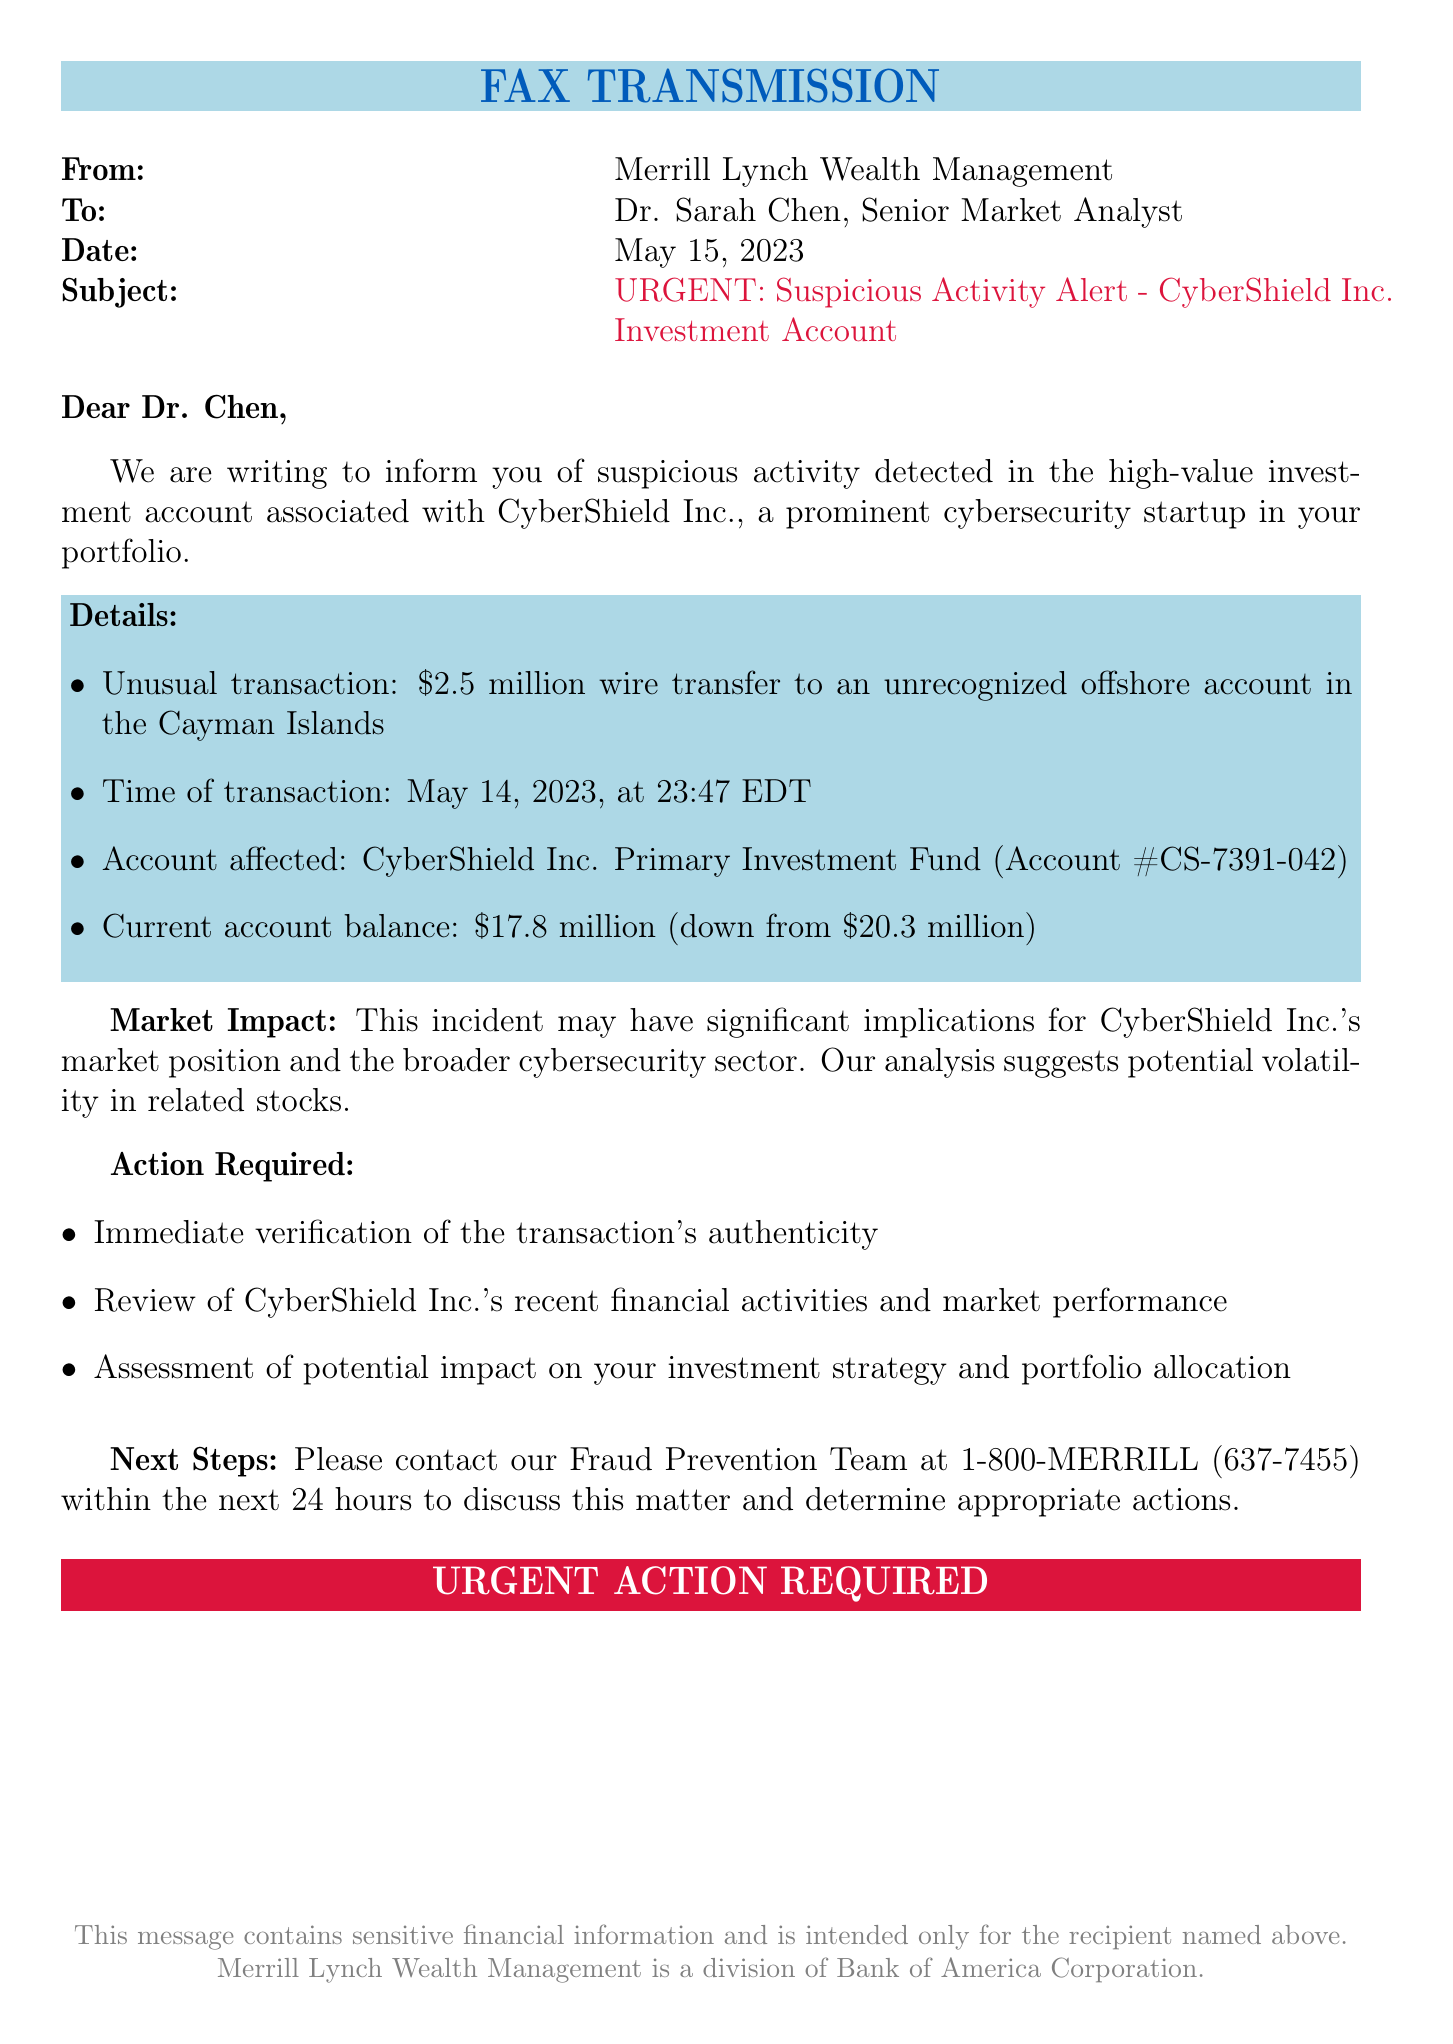What is the name of the company involved? The document highlights CyberShield Inc. as the company associated with the suspicious activity.
Answer: CyberShield Inc What is the amount of the suspicious transaction? The document specifies that the unusual transaction was a wire transfer of $2.5 million.
Answer: $2.5 million When did the suspicious transaction occur? The document states that the transaction took place on May 14, 2023, at 23:47 EDT.
Answer: May 14, 2023 What was the account balance before the suspicious transaction? The document indicates that the current account balance was $17.8 million, which was down from $20.3 million.
Answer: $20.3 million What action is required regarding the transaction's authenticity? The document requests immediate verification of the transaction's authenticity.
Answer: Immediate verification What is the role of Dr. Sarah Chen in this document? The document addresses Dr. Sarah Chen as a Senior Market Analyst.
Answer: Senior Market Analyst What is the contact number for the Fraud Prevention Team? The document provides the contact number as 1-800-MERRILL (637-7455).
Answer: 1-800-MERRILL (637-7455) What may this incident imply for the broader cybersecurity sector? The document suggests potential volatility in related stocks as a consequence of the incident.
Answer: Volatility in related stocks How is this document classified? The document is classified as a fax transmission based on its header.
Answer: Fax transmission 